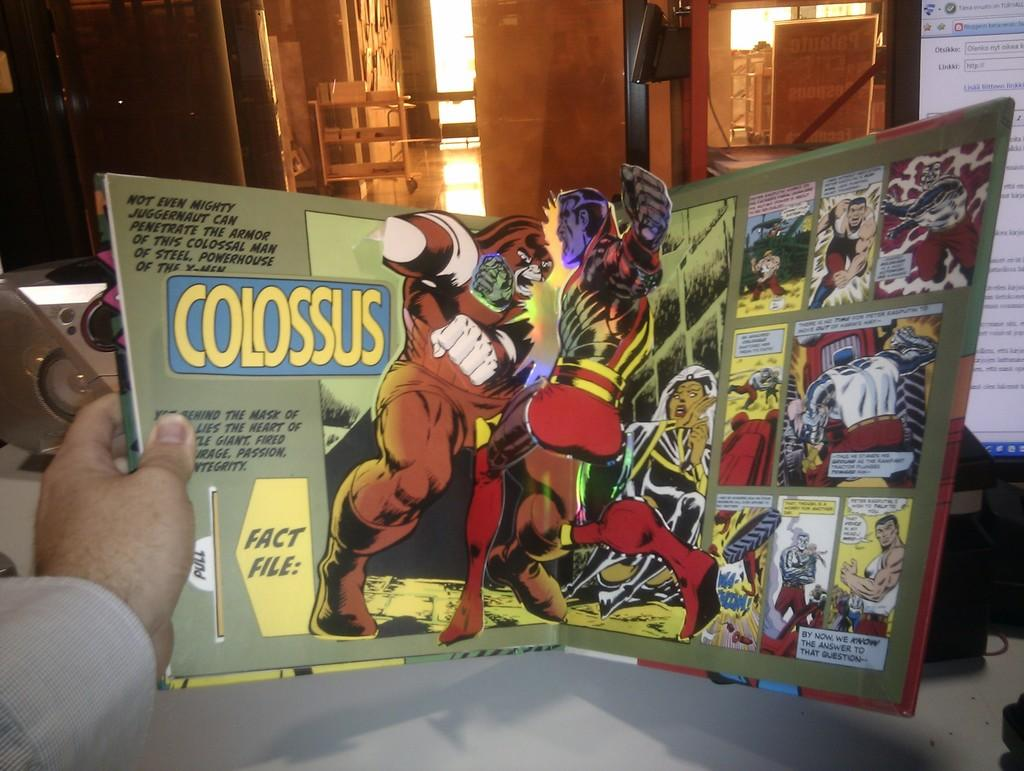<image>
Present a compact description of the photo's key features. A pop up book is open to a battle between Juggernaut and Colossus. 